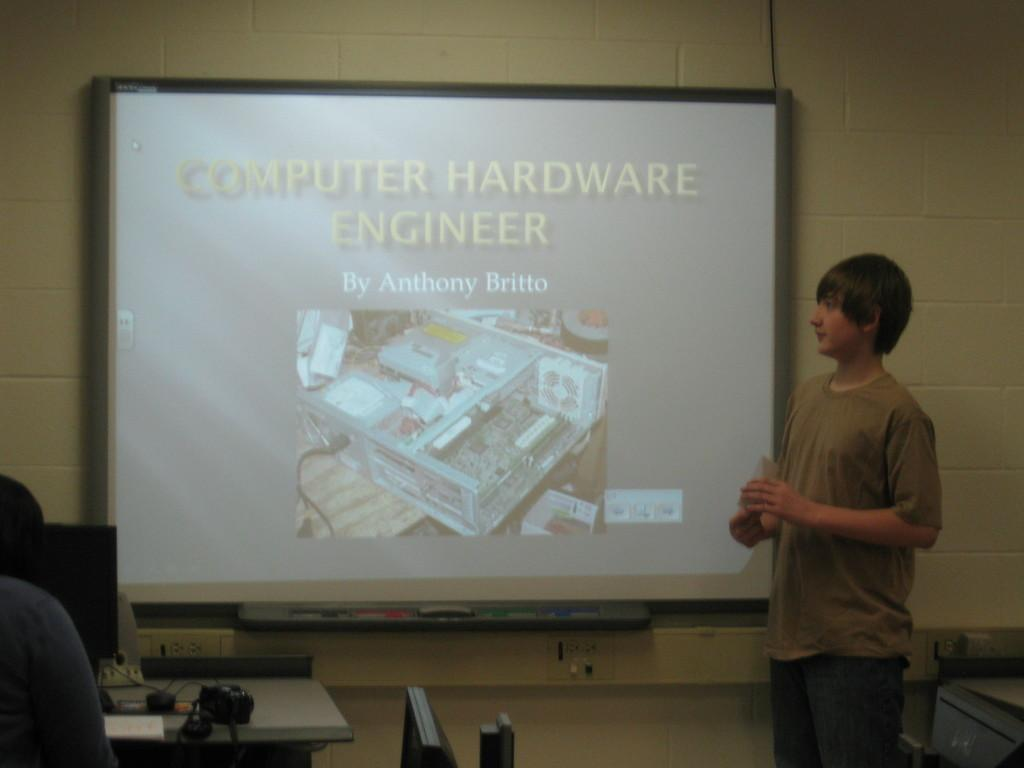Who is the main subject in the image? There is a boy in the image. What is the boy wearing? The boy is wearing a brown t-shirt. Where is the boy positioned in the image? The boy is standing in front of a screen. What other objects can be seen in the image? There is a table in the image, and a switch board is present on the table. What type of glove is the boy wearing in the image? There is no glove visible in the image; the boy is wearing a brown t-shirt. How many times does the boy sneeze in the image? There is no indication of the boy sneezing in the image; he is simply standing in front of a screen. 